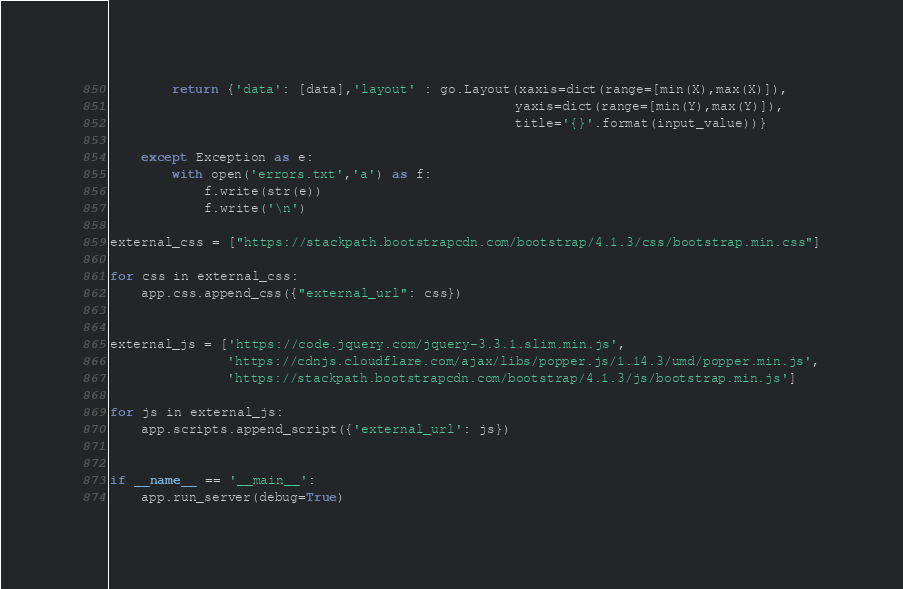<code> <loc_0><loc_0><loc_500><loc_500><_Python_>
        return {'data': [data],'layout' : go.Layout(xaxis=dict(range=[min(X),max(X)]),
                                                    yaxis=dict(range=[min(Y),max(Y)]),
                                                    title='{}'.format(input_value))}

    except Exception as e:
        with open('errors.txt','a') as f:
            f.write(str(e))
            f.write('\n')            

external_css = ["https://stackpath.bootstrapcdn.com/bootstrap/4.1.3/css/bootstrap.min.css"]

for css in external_css:
    app.css.append_css({"external_url": css})


external_js = ['https://code.jquery.com/jquery-3.3.1.slim.min.js',
               'https://cdnjs.cloudflare.com/ajax/libs/popper.js/1.14.3/umd/popper.min.js',
               'https://stackpath.bootstrapcdn.com/bootstrap/4.1.3/js/bootstrap.min.js']

for js in external_js:
    app.scripts.append_script({'external_url': js})


if __name__ == '__main__':
    app.run_server(debug=True)
</code> 